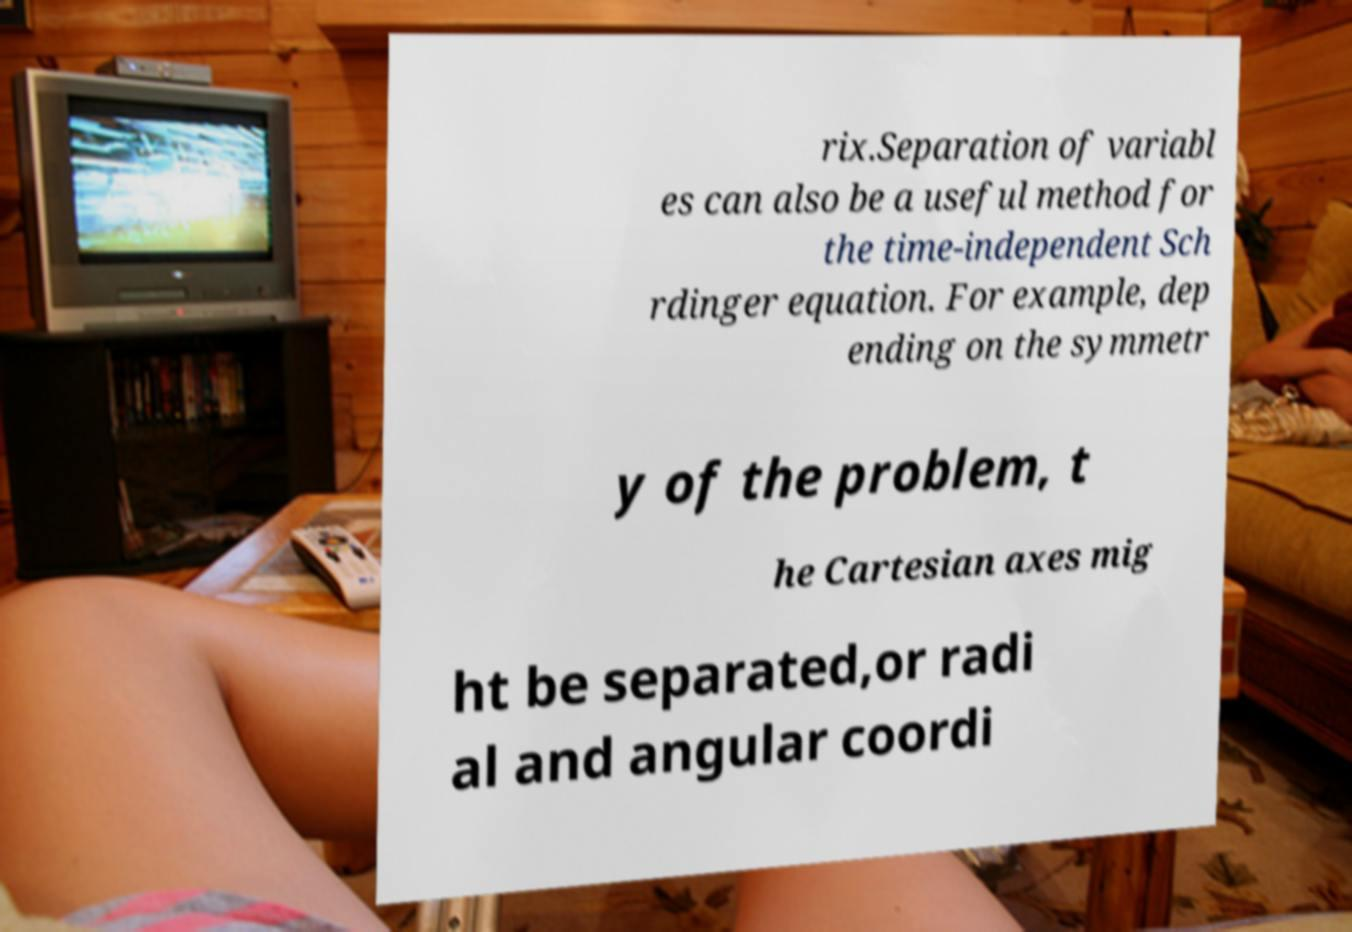There's text embedded in this image that I need extracted. Can you transcribe it verbatim? rix.Separation of variabl es can also be a useful method for the time-independent Sch rdinger equation. For example, dep ending on the symmetr y of the problem, t he Cartesian axes mig ht be separated,or radi al and angular coordi 